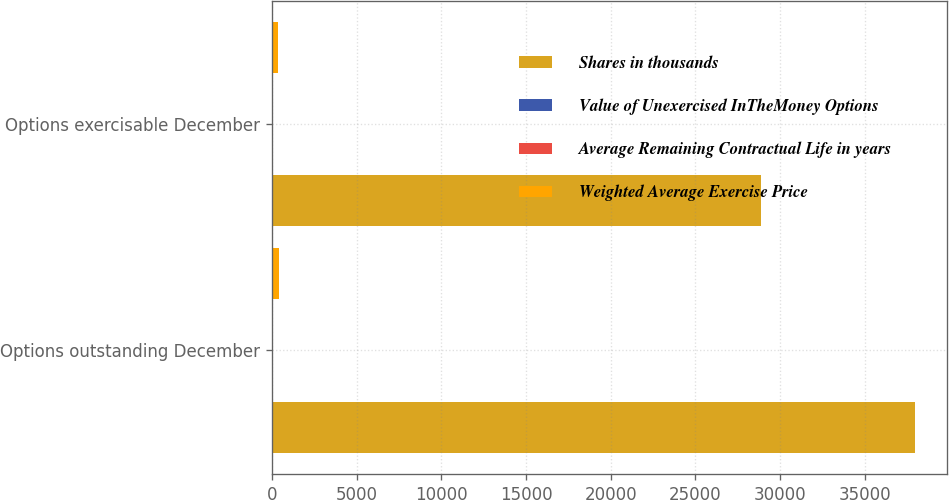Convert chart. <chart><loc_0><loc_0><loc_500><loc_500><stacked_bar_chart><ecel><fcel>Options outstanding December<fcel>Options exercisable December<nl><fcel>Shares in thousands<fcel>37952<fcel>28905<nl><fcel>Value of Unexercised InTheMoney Options<fcel>54<fcel>53<nl><fcel>Average Remaining Contractual Life in years<fcel>3<fcel>3<nl><fcel>Weighted Average Exercise Price<fcel>430<fcel>358<nl></chart> 